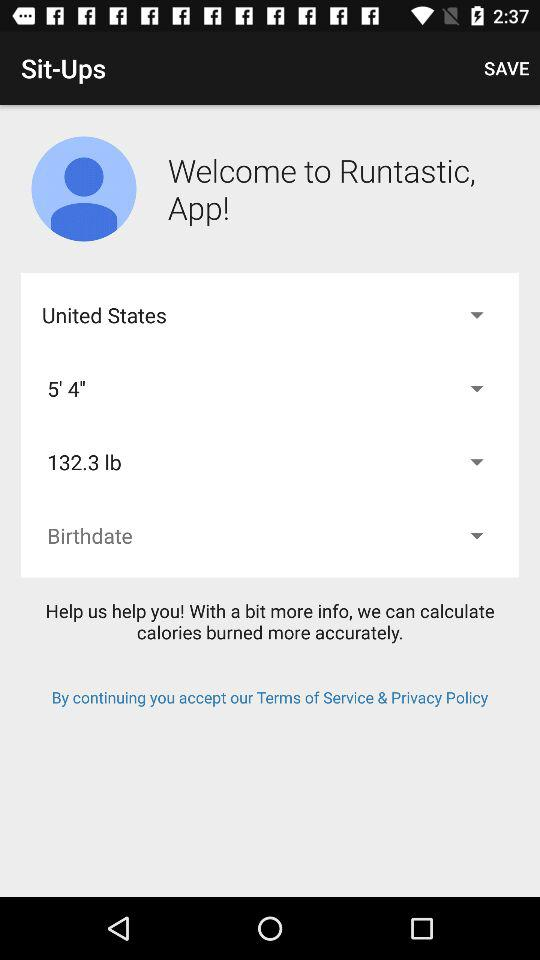What is the height? The height is 5 feet 4 inches. 